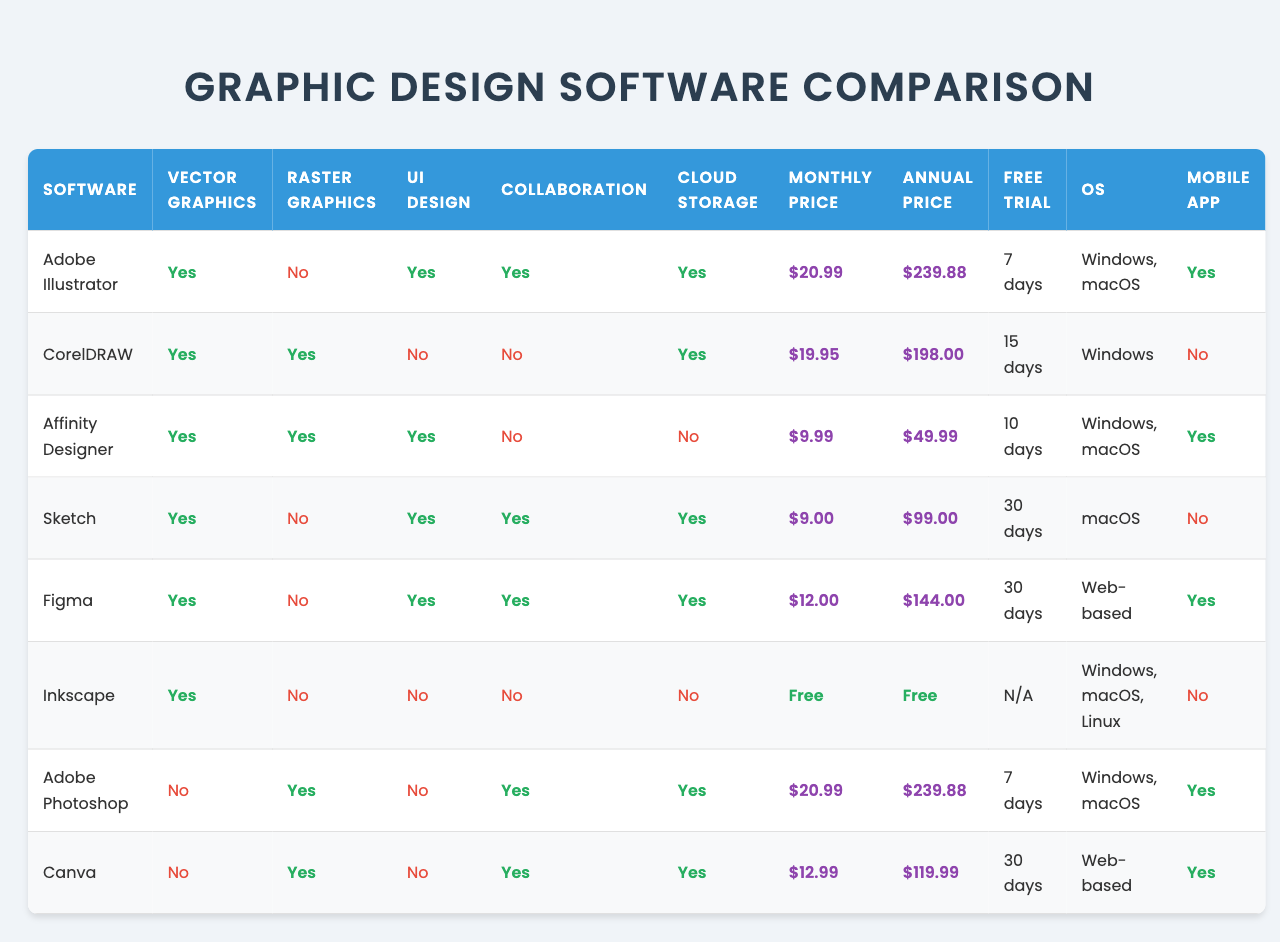What software offers vector graphics capabilities? By checking the "Vector Graphics" column in the table, I can see that the software offering this feature includes Adobe Illustrator, CorelDRAW, Affinity Designer, Sketch, Figma, and Inkscape.
Answer: Adobe Illustrator, CorelDRAW, Affinity Designer, Sketch, Figma, Inkscape Which software has a free version? The "Monthly Subscription Price" and "Annual Subscription Price" columns show that Inkscape is the only software with a price of 0, indicating it's free.
Answer: Inkscape How much is the monthly subscription for Affinity Designer? By looking at the "Monthly Subscription Price" column for Affinity Designer, the value is $9.99.
Answer: $9.99 Which software supports collaboration features? The "Collaboration Features" column shows that Adobe Illustrator, Sketch, Figma, and Canva offer this feature.
Answer: Adobe Illustrator, Sketch, Figma, Canva What is the price difference between the monthly subscription of Adobe Photoshop and Canva? The monthly subscription for Adobe Photoshop is $20.99 and for Canva is $12.99. The difference is $20.99 - $12.99 = $8.00.
Answer: $8.00 Are CorelDRAW and Sketch available on the same operating systems? Checking the "Operating System" column, CorelDRAW is available only on Windows, while Sketch is available only on macOS, meaning they do not share any operating systems.
Answer: No Which software has the longest free trial period? Looking at the "Free Trial Days" column, I see that both Sketch and Figma offer a free trial for 30 days, which is the longest duration compared to others.
Answer: Sketch, Figma Does Adobe Illustrator have mobile app support? The "Mobile App Available" column shows that Adobe Illustrator does have a mobile app available, indicated by 'Yes'.
Answer: Yes What is the average monthly subscription price for the software listed? The monthly subscription prices are $20.99, $19.95, $9.99, $9, $12, $0, $20.99, and $12.99, totalling $105.90. Dividing by 8 (the number of software), the average is $105.90 / 8 = $13.24.
Answer: $13.24 Which software is not available for Windows OS? By reviewing the "Operating System" column, the software not available for Windows is Sketch and Canva, since Sketch is only on macOS and Canva is web-based but has no Windows-specific app.
Answer: Sketch, Canva 